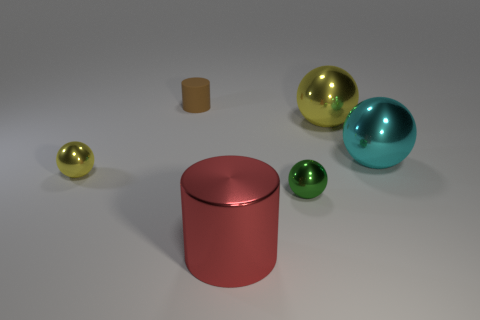Could you describe the lighting condition and shadows in the scene? Certainly, the image showcases a softly lit scene with diffused lighting, possibly simulating an indoor environment with ambient light. Shadows are soft-edged and cast directly beneath the objects, which indicates the light source is positioned above the scene, slightly favoring the left side given the shadow positions. No harsh shadows suggest that the source is not overly bright and casts a gentle illumination across the entire scene. 